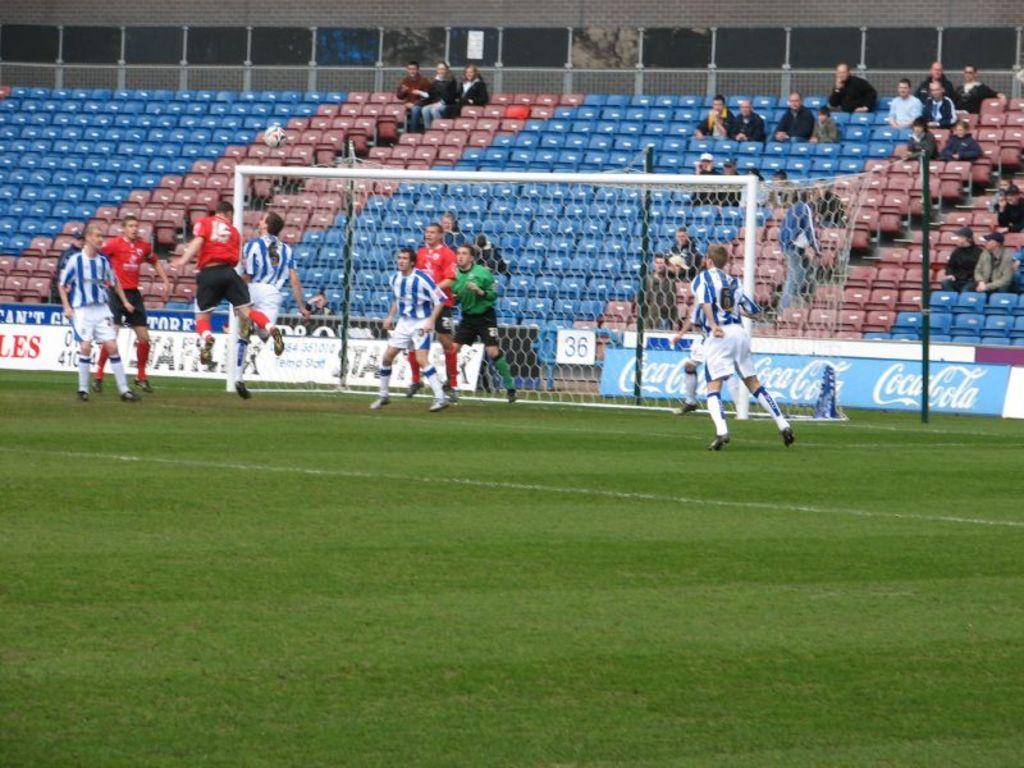Who is a sponsor of the game?
Your answer should be very brief. Coca cola. What number is in the back by the net?
Keep it short and to the point. 36. 